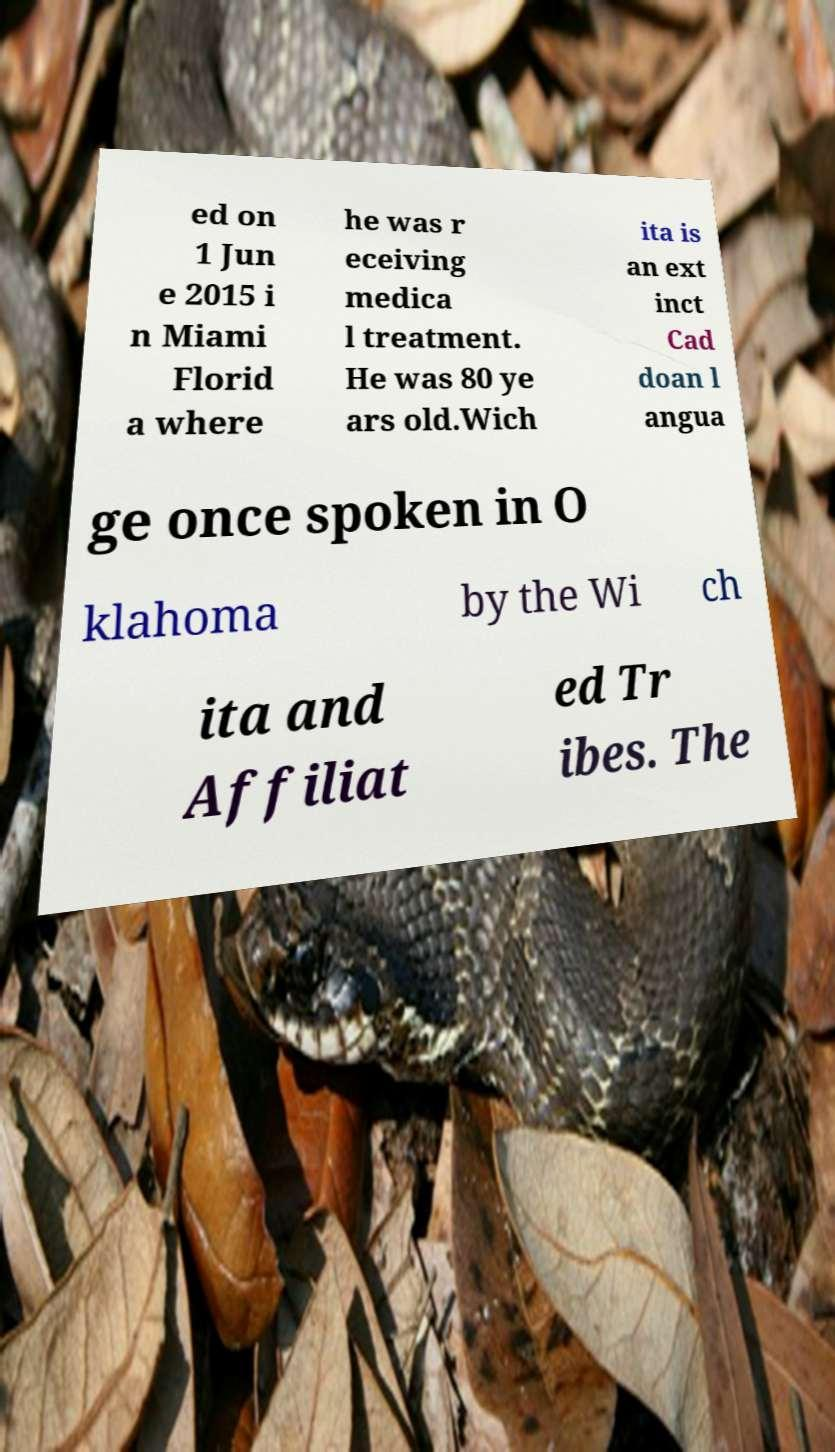I need the written content from this picture converted into text. Can you do that? ed on 1 Jun e 2015 i n Miami Florid a where he was r eceiving medica l treatment. He was 80 ye ars old.Wich ita is an ext inct Cad doan l angua ge once spoken in O klahoma by the Wi ch ita and Affiliat ed Tr ibes. The 